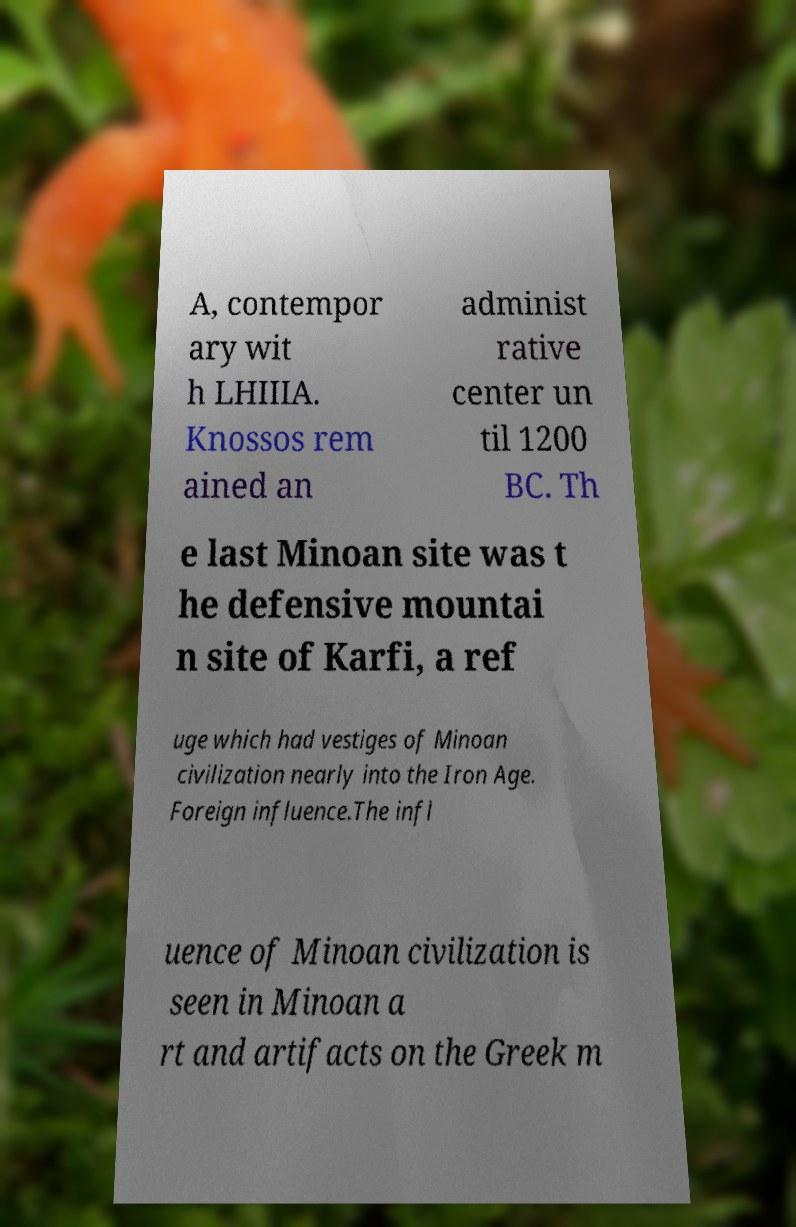What messages or text are displayed in this image? I need them in a readable, typed format. A, contempor ary wit h LHIIIA. Knossos rem ained an administ rative center un til 1200 BC. Th e last Minoan site was t he defensive mountai n site of Karfi, a ref uge which had vestiges of Minoan civilization nearly into the Iron Age. Foreign influence.The infl uence of Minoan civilization is seen in Minoan a rt and artifacts on the Greek m 